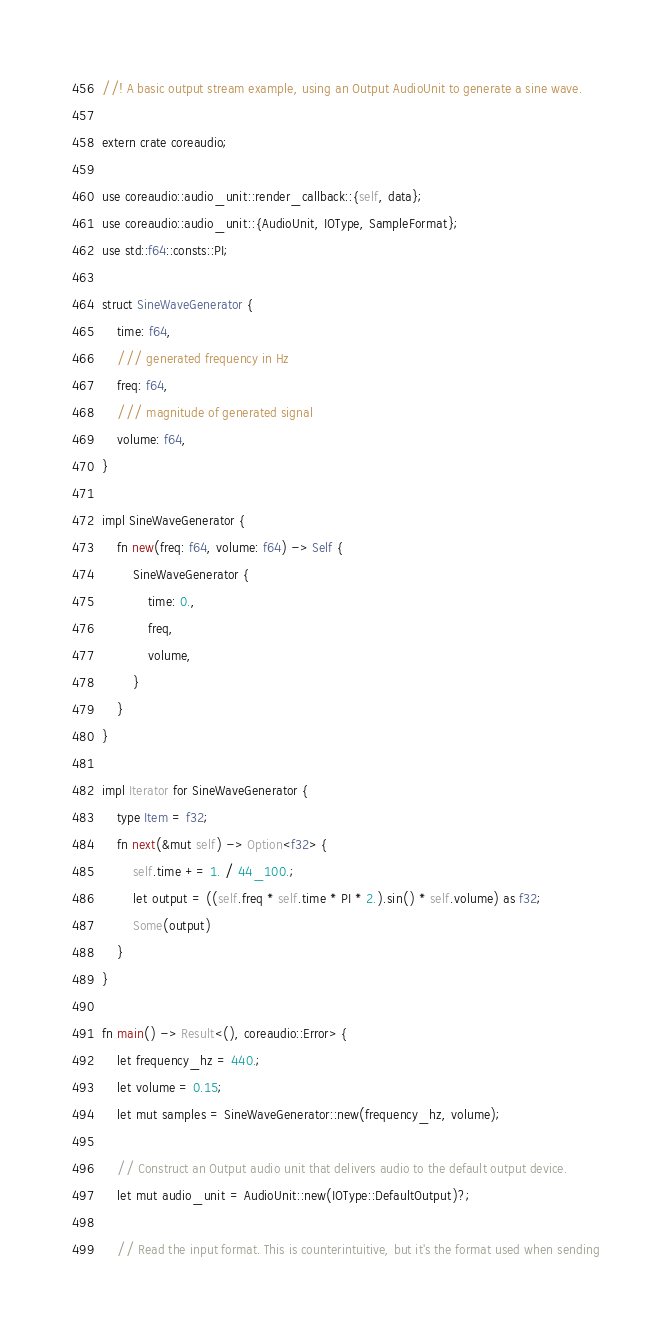<code> <loc_0><loc_0><loc_500><loc_500><_Rust_>//! A basic output stream example, using an Output AudioUnit to generate a sine wave.

extern crate coreaudio;

use coreaudio::audio_unit::render_callback::{self, data};
use coreaudio::audio_unit::{AudioUnit, IOType, SampleFormat};
use std::f64::consts::PI;

struct SineWaveGenerator {
    time: f64,
    /// generated frequency in Hz
    freq: f64,
    /// magnitude of generated signal
    volume: f64,
}

impl SineWaveGenerator {
    fn new(freq: f64, volume: f64) -> Self {
        SineWaveGenerator {
            time: 0.,
            freq,
            volume,
        }
    }
}

impl Iterator for SineWaveGenerator {
    type Item = f32;
    fn next(&mut self) -> Option<f32> {
        self.time += 1. / 44_100.;
        let output = ((self.freq * self.time * PI * 2.).sin() * self.volume) as f32;
        Some(output)
    }
}

fn main() -> Result<(), coreaudio::Error> {
    let frequency_hz = 440.;
    let volume = 0.15;
    let mut samples = SineWaveGenerator::new(frequency_hz, volume);

    // Construct an Output audio unit that delivers audio to the default output device.
    let mut audio_unit = AudioUnit::new(IOType::DefaultOutput)?;

    // Read the input format. This is counterintuitive, but it's the format used when sending</code> 